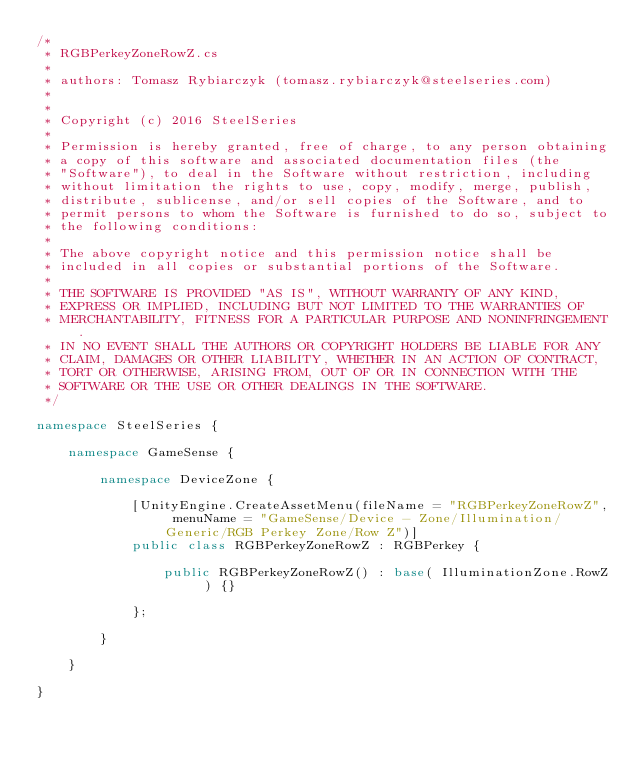Convert code to text. <code><loc_0><loc_0><loc_500><loc_500><_C#_>/*
 * RGBPerkeyZoneRowZ.cs
 *
 * authors: Tomasz Rybiarczyk (tomasz.rybiarczyk@steelseries.com)
 *
 *
 * Copyright (c) 2016 SteelSeries
 *
 * Permission is hereby granted, free of charge, to any person obtaining
 * a copy of this software and associated documentation files (the
 * "Software"), to deal in the Software without restriction, including
 * without limitation the rights to use, copy, modify, merge, publish,
 * distribute, sublicense, and/or sell copies of the Software, and to
 * permit persons to whom the Software is furnished to do so, subject to
 * the following conditions:
 *
 * The above copyright notice and this permission notice shall be
 * included in all copies or substantial portions of the Software.
 *
 * THE SOFTWARE IS PROVIDED "AS IS", WITHOUT WARRANTY OF ANY KIND,
 * EXPRESS OR IMPLIED, INCLUDING BUT NOT LIMITED TO THE WARRANTIES OF
 * MERCHANTABILITY, FITNESS FOR A PARTICULAR PURPOSE AND NONINFRINGEMENT.
 * IN NO EVENT SHALL THE AUTHORS OR COPYRIGHT HOLDERS BE LIABLE FOR ANY
 * CLAIM, DAMAGES OR OTHER LIABILITY, WHETHER IN AN ACTION OF CONTRACT,
 * TORT OR OTHERWISE, ARISING FROM, OUT OF OR IN CONNECTION WITH THE
 * SOFTWARE OR THE USE OR OTHER DEALINGS IN THE SOFTWARE.
 */

namespace SteelSeries {

    namespace GameSense {

        namespace DeviceZone {

            [UnityEngine.CreateAssetMenu(fileName = "RGBPerkeyZoneRowZ", menuName = "GameSense/Device - Zone/Illumination/Generic/RGB Perkey Zone/Row Z")]
            public class RGBPerkeyZoneRowZ : RGBPerkey {

                public RGBPerkeyZoneRowZ() : base( IlluminationZone.RowZ ) {}

            };

        }

    }

}</code> 